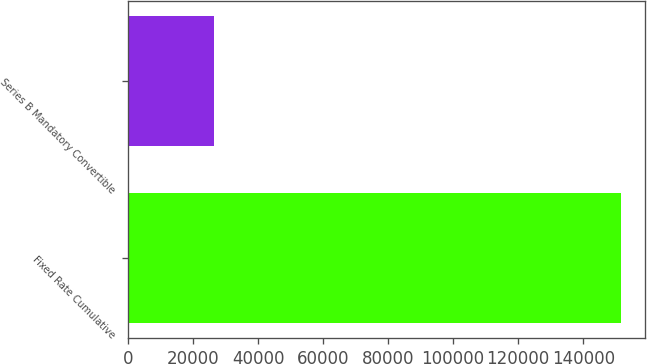Convert chart. <chart><loc_0><loc_0><loc_500><loc_500><bar_chart><fcel>Fixed Rate Cumulative<fcel>Series B Mandatory Convertible<nl><fcel>151500<fcel>26500<nl></chart> 